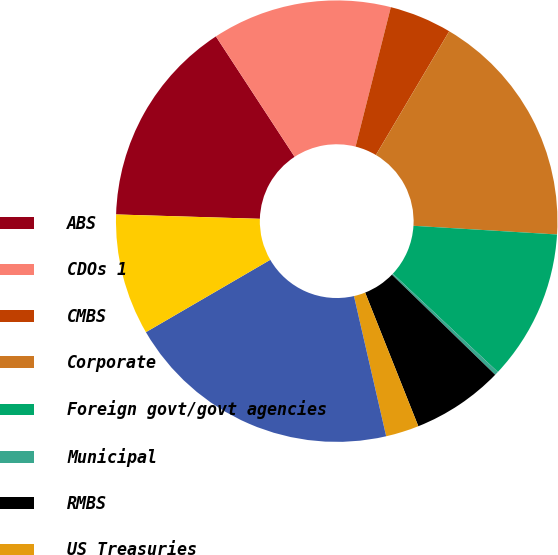Convert chart to OTSL. <chart><loc_0><loc_0><loc_500><loc_500><pie_chart><fcel>ABS<fcel>CDOs 1<fcel>CMBS<fcel>Corporate<fcel>Foreign govt/govt agencies<fcel>Municipal<fcel>RMBS<fcel>US Treasuries<fcel>Total fixed maturities AFS<fcel>Equity securities AFS 2<nl><fcel>15.3%<fcel>13.16%<fcel>4.57%<fcel>17.45%<fcel>11.01%<fcel>0.28%<fcel>6.72%<fcel>2.43%<fcel>20.21%<fcel>8.87%<nl></chart> 